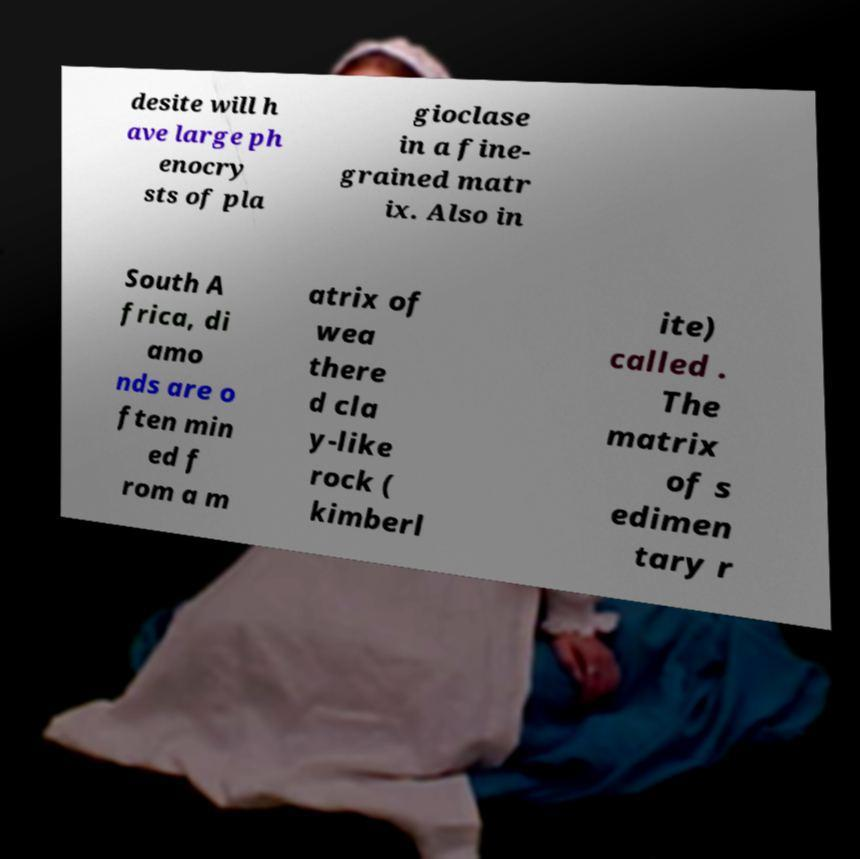Please identify and transcribe the text found in this image. desite will h ave large ph enocry sts of pla gioclase in a fine- grained matr ix. Also in South A frica, di amo nds are o ften min ed f rom a m atrix of wea there d cla y-like rock ( kimberl ite) called . The matrix of s edimen tary r 